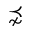<formula> <loc_0><loc_0><loc_500><loc_500>\precnsim</formula> 